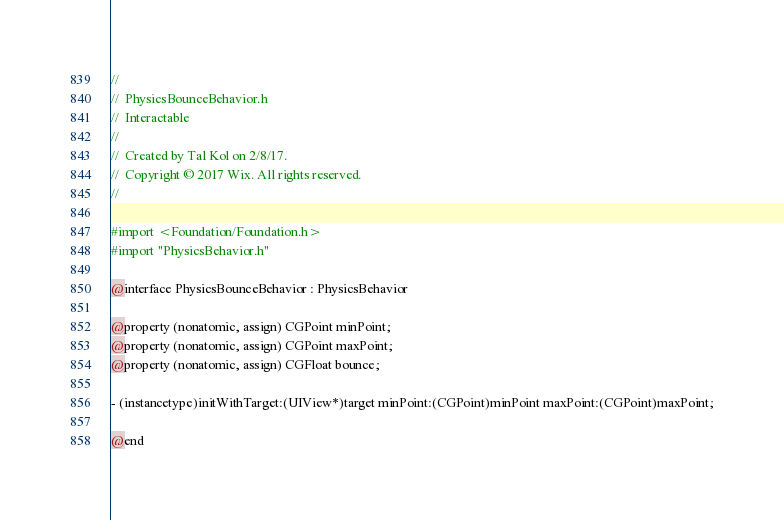<code> <loc_0><loc_0><loc_500><loc_500><_C_>//
//  PhysicsBounceBehavior.h
//  Interactable
//
//  Created by Tal Kol on 2/8/17.
//  Copyright © 2017 Wix. All rights reserved.
//

#import <Foundation/Foundation.h>
#import "PhysicsBehavior.h"

@interface PhysicsBounceBehavior : PhysicsBehavior

@property (nonatomic, assign) CGPoint minPoint;
@property (nonatomic, assign) CGPoint maxPoint;
@property (nonatomic, assign) CGFloat bounce;

- (instancetype)initWithTarget:(UIView*)target minPoint:(CGPoint)minPoint maxPoint:(CGPoint)maxPoint;

@end
</code> 